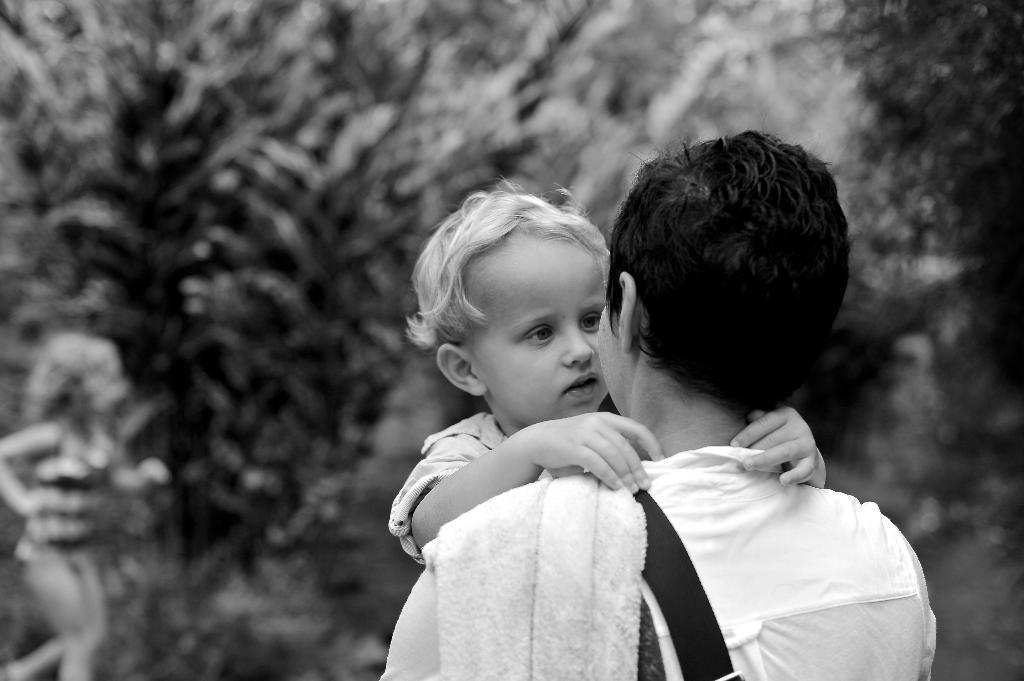In one or two sentences, can you explain what this image depicts? In this image in the middle there is a person wearing a shirt, cloth and holding a baby. In the background there are trees and a girl. 